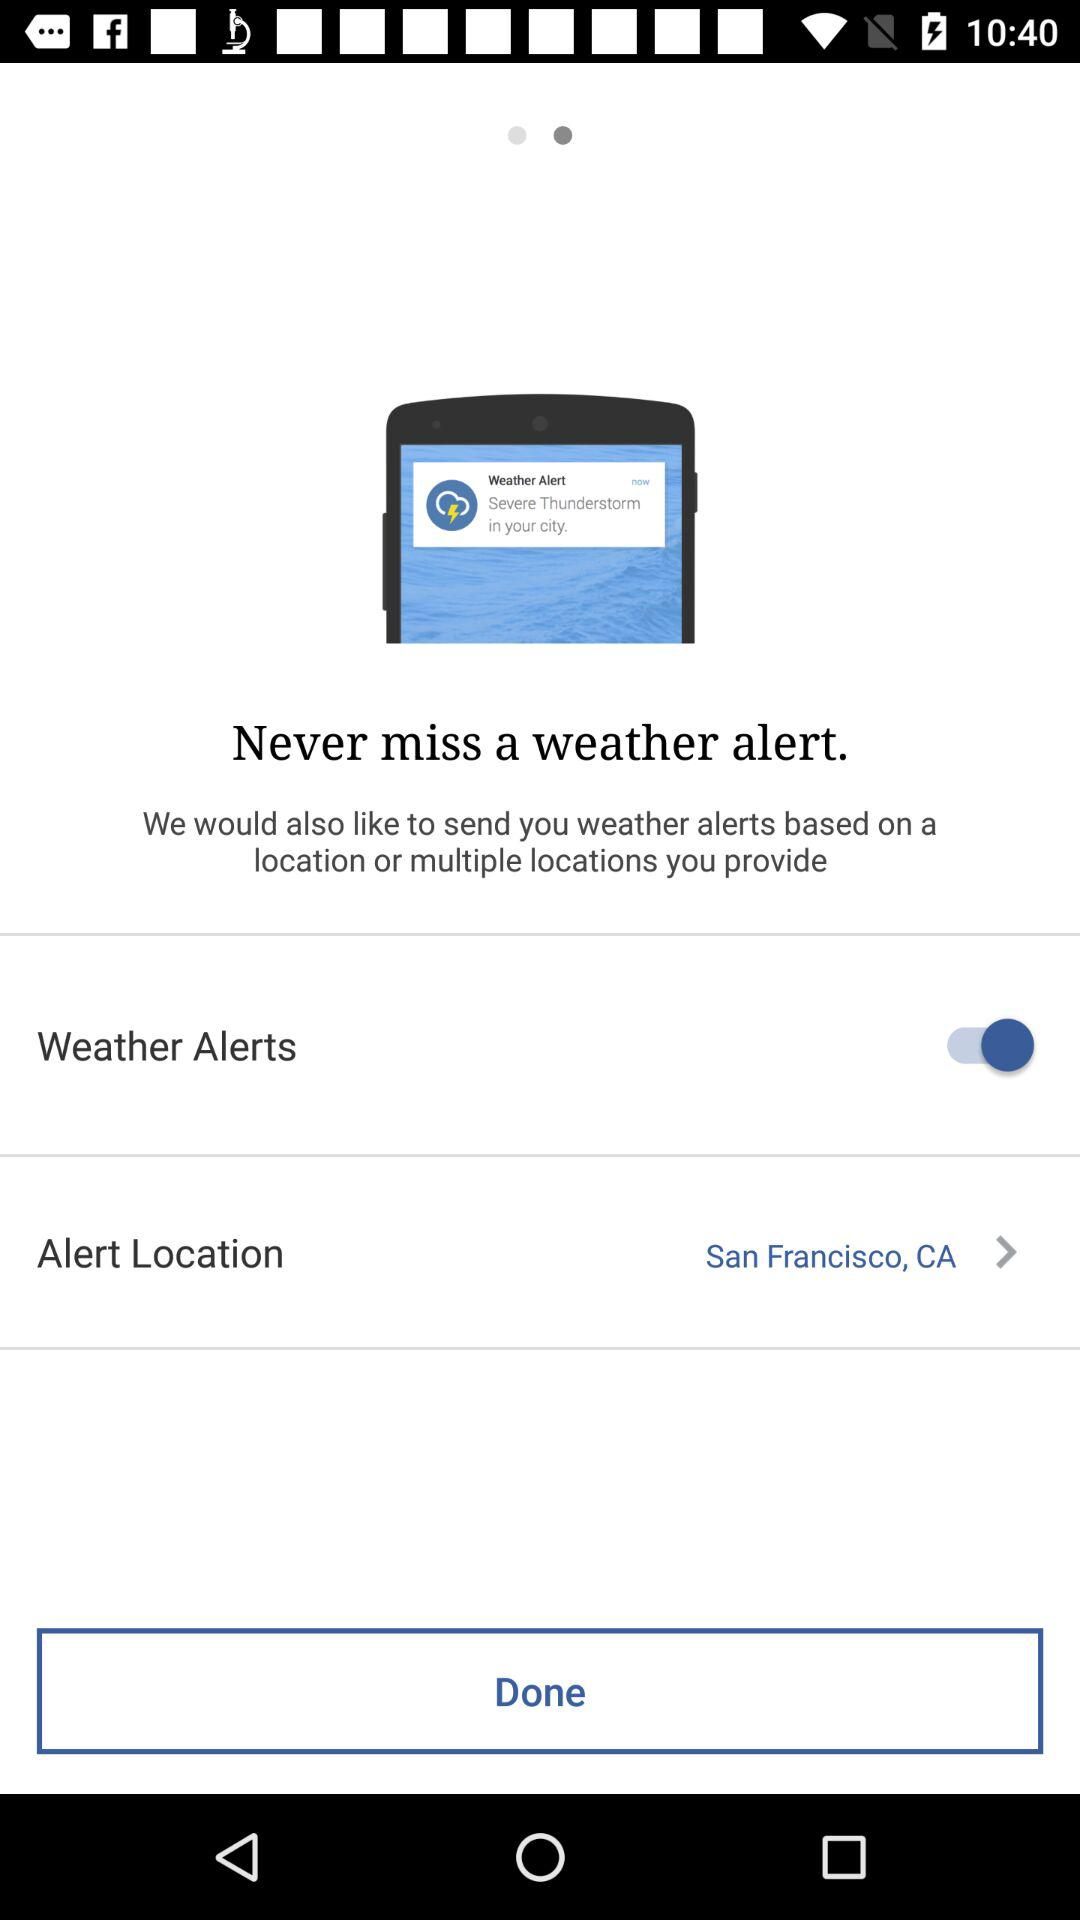What is the "Alert Location"? The "Alert Location" is San Francisco, CA. 